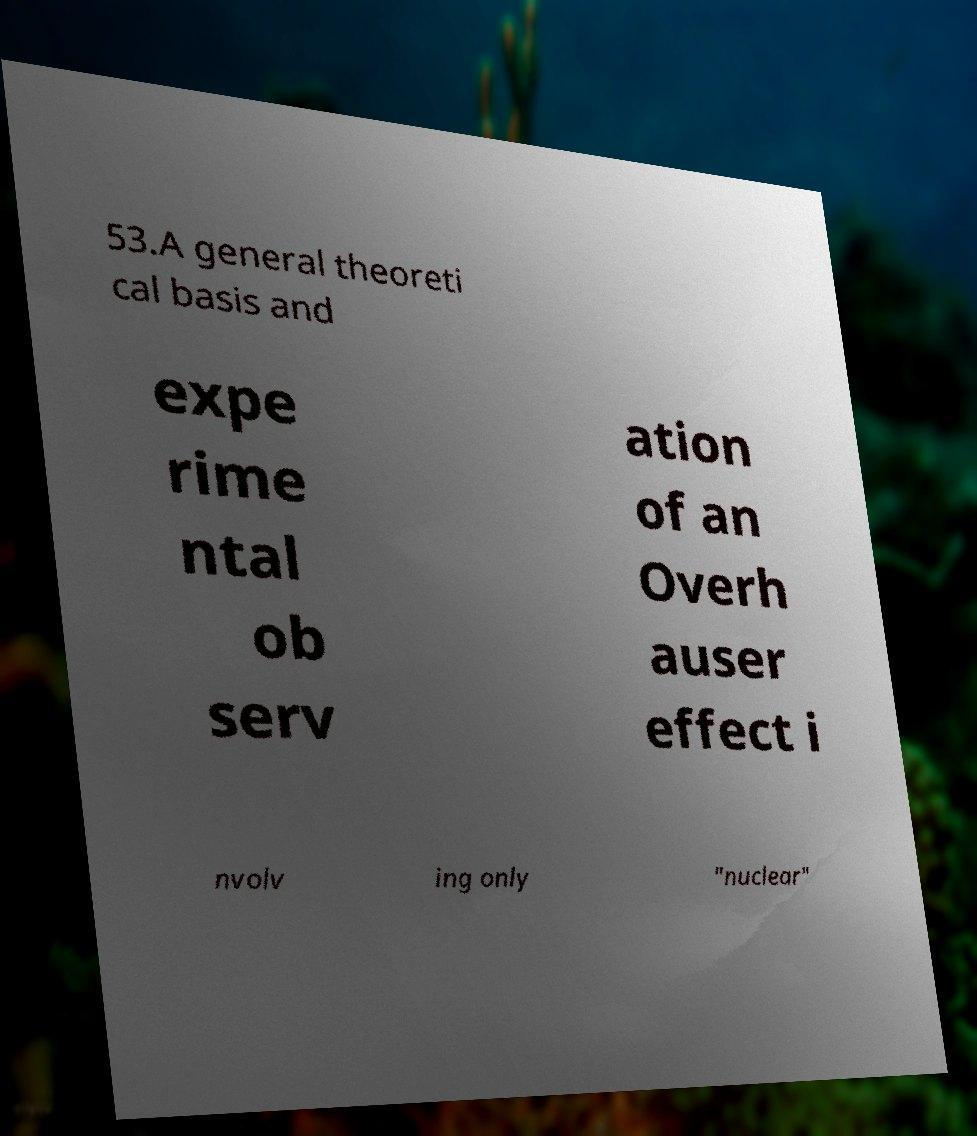Please identify and transcribe the text found in this image. 53.A general theoreti cal basis and expe rime ntal ob serv ation of an Overh auser effect i nvolv ing only "nuclear" 